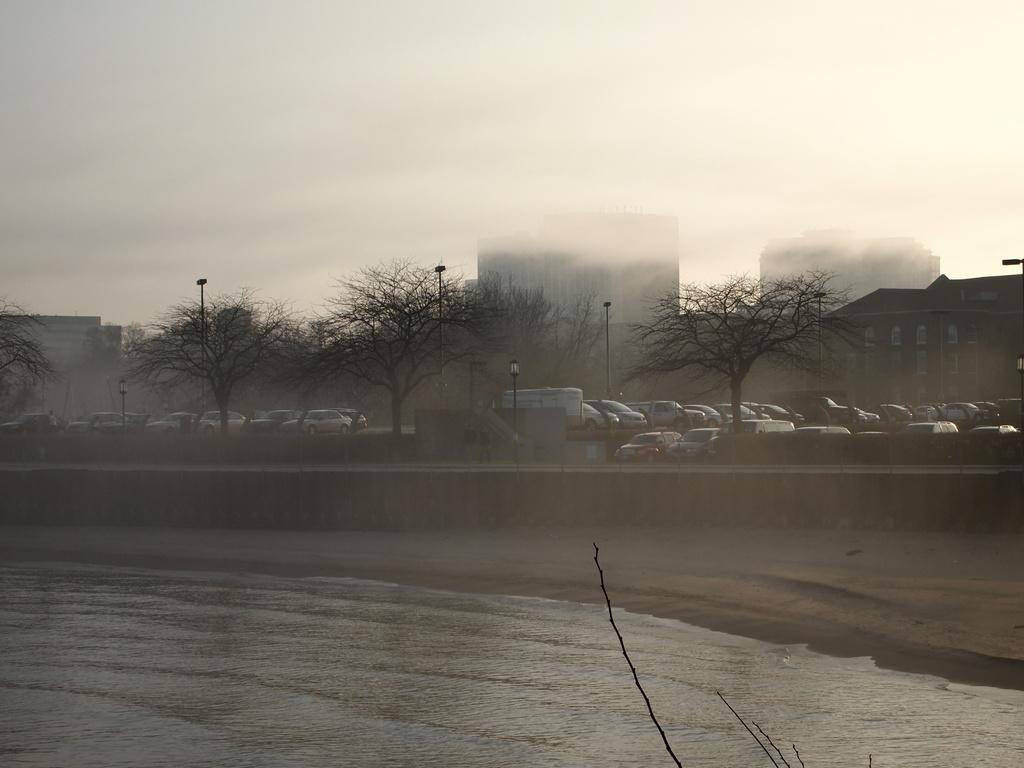What is visible in the image? Water, branches, trees, vehicles, lights on poles, buildings, and the sky are visible in the image. Can you describe the background of the image? The background of the image includes trees, vehicles, lights on poles, buildings, and the sky. What type of environment might this image depict? The image might depict an urban or suburban environment, given the presence of vehicles, lights on poles, and buildings. What time does the clock in the image show? There is no clock present in the image. What type of offer is being made by the person in the image? There is no person or offer present in the image. 